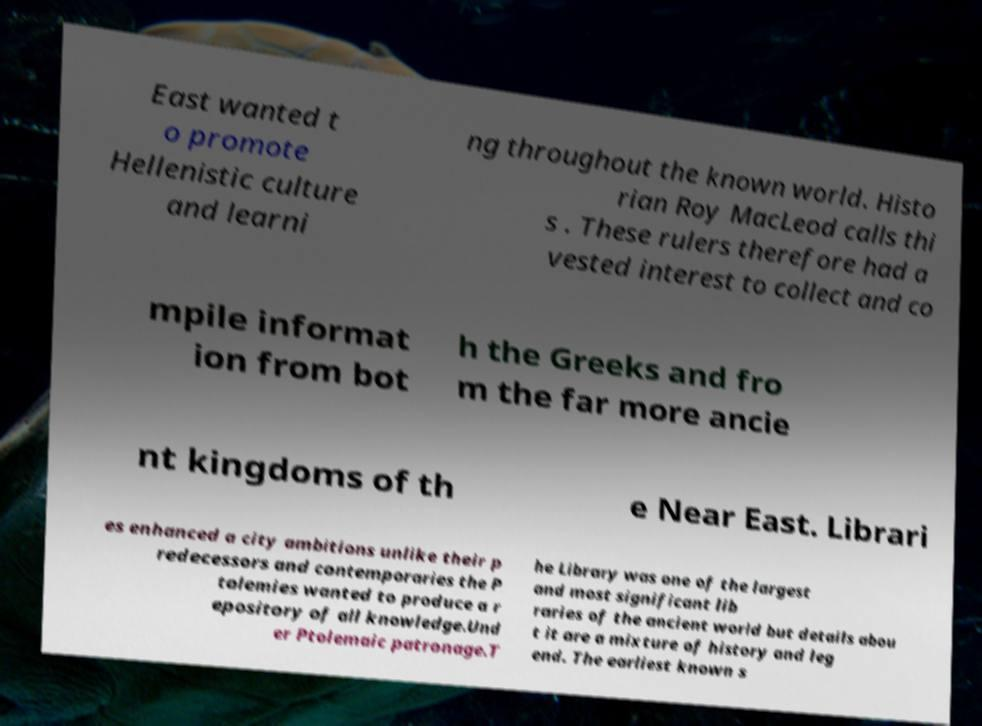There's text embedded in this image that I need extracted. Can you transcribe it verbatim? East wanted t o promote Hellenistic culture and learni ng throughout the known world. Histo rian Roy MacLeod calls thi s . These rulers therefore had a vested interest to collect and co mpile informat ion from bot h the Greeks and fro m the far more ancie nt kingdoms of th e Near East. Librari es enhanced a city ambitions unlike their p redecessors and contemporaries the P tolemies wanted to produce a r epository of all knowledge.Und er Ptolemaic patronage.T he Library was one of the largest and most significant lib raries of the ancient world but details abou t it are a mixture of history and leg end. The earliest known s 